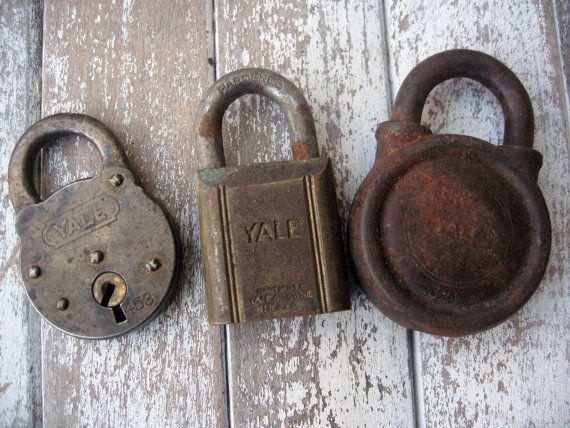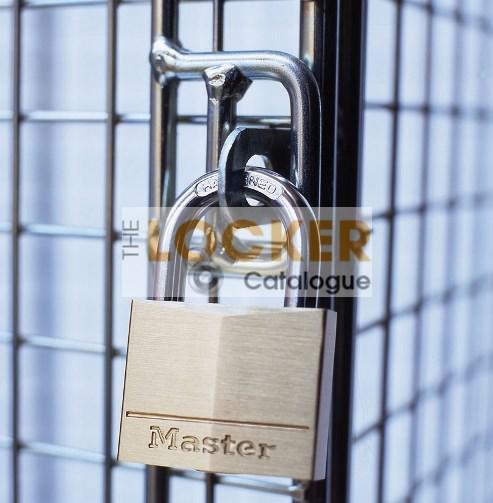The first image is the image on the left, the second image is the image on the right. Assess this claim about the two images: "there are newly never opened locks in packaging". Correct or not? Answer yes or no. No. The first image is the image on the left, the second image is the image on the right. Given the left and right images, does the statement "The leftmost image contains exactly 3 tarnished old locks, not brand new or in packages." hold true? Answer yes or no. Yes. 